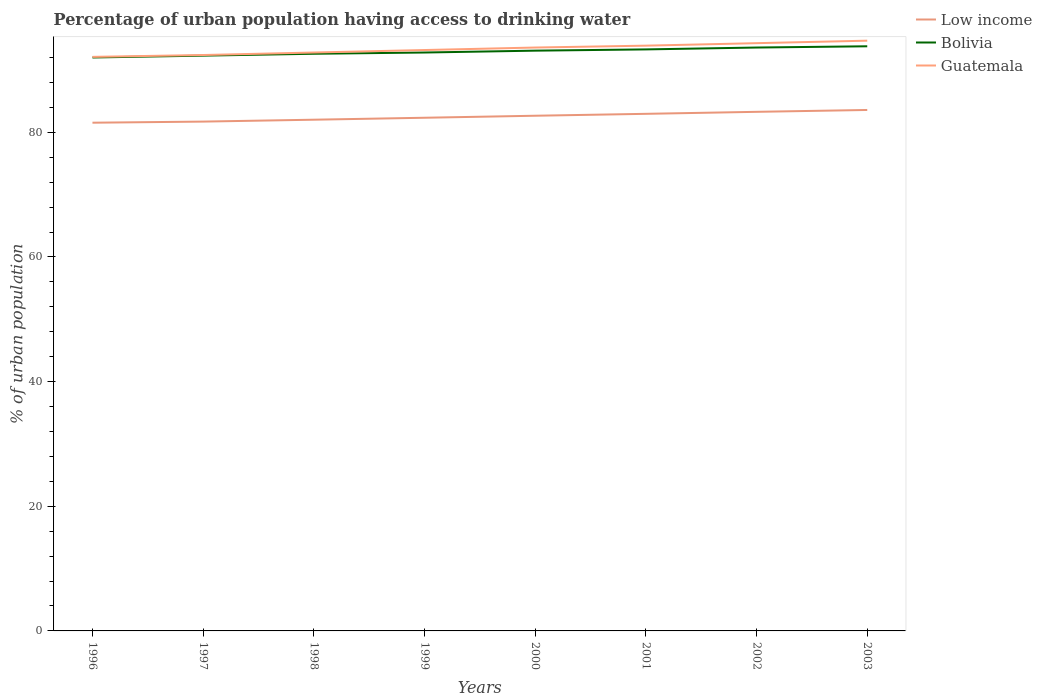How many different coloured lines are there?
Give a very brief answer. 3. Is the number of lines equal to the number of legend labels?
Offer a very short reply. Yes. Across all years, what is the maximum percentage of urban population having access to drinking water in Guatemala?
Give a very brief answer. 92.1. What is the total percentage of urban population having access to drinking water in Low income in the graph?
Your answer should be compact. -1.75. What is the difference between the highest and the second highest percentage of urban population having access to drinking water in Bolivia?
Your response must be concise. 1.8. Is the percentage of urban population having access to drinking water in Bolivia strictly greater than the percentage of urban population having access to drinking water in Guatemala over the years?
Make the answer very short. Yes. Are the values on the major ticks of Y-axis written in scientific E-notation?
Give a very brief answer. No. Does the graph contain grids?
Your answer should be very brief. No. Where does the legend appear in the graph?
Make the answer very short. Top right. What is the title of the graph?
Give a very brief answer. Percentage of urban population having access to drinking water. What is the label or title of the X-axis?
Your response must be concise. Years. What is the label or title of the Y-axis?
Offer a terse response. % of urban population. What is the % of urban population in Low income in 1996?
Ensure brevity in your answer.  81.54. What is the % of urban population in Bolivia in 1996?
Ensure brevity in your answer.  92. What is the % of urban population in Guatemala in 1996?
Offer a very short reply. 92.1. What is the % of urban population in Low income in 1997?
Give a very brief answer. 81.72. What is the % of urban population in Bolivia in 1997?
Your answer should be compact. 92.3. What is the % of urban population in Guatemala in 1997?
Ensure brevity in your answer.  92.4. What is the % of urban population in Low income in 1998?
Give a very brief answer. 82.02. What is the % of urban population of Bolivia in 1998?
Provide a short and direct response. 92.6. What is the % of urban population in Guatemala in 1998?
Offer a very short reply. 92.8. What is the % of urban population in Low income in 1999?
Make the answer very short. 82.33. What is the % of urban population in Bolivia in 1999?
Offer a terse response. 92.8. What is the % of urban population in Guatemala in 1999?
Give a very brief answer. 93.2. What is the % of urban population of Low income in 2000?
Provide a short and direct response. 82.66. What is the % of urban population of Bolivia in 2000?
Your answer should be very brief. 93.1. What is the % of urban population in Guatemala in 2000?
Provide a short and direct response. 93.6. What is the % of urban population in Low income in 2001?
Keep it short and to the point. 82.96. What is the % of urban population in Bolivia in 2001?
Provide a succinct answer. 93.3. What is the % of urban population of Guatemala in 2001?
Provide a short and direct response. 93.9. What is the % of urban population of Low income in 2002?
Make the answer very short. 83.28. What is the % of urban population of Bolivia in 2002?
Give a very brief answer. 93.6. What is the % of urban population of Guatemala in 2002?
Provide a succinct answer. 94.3. What is the % of urban population of Low income in 2003?
Your response must be concise. 83.58. What is the % of urban population of Bolivia in 2003?
Your answer should be very brief. 93.8. What is the % of urban population in Guatemala in 2003?
Make the answer very short. 94.7. Across all years, what is the maximum % of urban population in Low income?
Your response must be concise. 83.58. Across all years, what is the maximum % of urban population of Bolivia?
Make the answer very short. 93.8. Across all years, what is the maximum % of urban population of Guatemala?
Provide a short and direct response. 94.7. Across all years, what is the minimum % of urban population in Low income?
Make the answer very short. 81.54. Across all years, what is the minimum % of urban population of Bolivia?
Offer a terse response. 92. Across all years, what is the minimum % of urban population in Guatemala?
Your response must be concise. 92.1. What is the total % of urban population of Low income in the graph?
Your response must be concise. 660.1. What is the total % of urban population of Bolivia in the graph?
Ensure brevity in your answer.  743.5. What is the total % of urban population of Guatemala in the graph?
Your response must be concise. 747. What is the difference between the % of urban population in Low income in 1996 and that in 1997?
Provide a succinct answer. -0.18. What is the difference between the % of urban population of Bolivia in 1996 and that in 1997?
Offer a terse response. -0.3. What is the difference between the % of urban population in Low income in 1996 and that in 1998?
Ensure brevity in your answer.  -0.48. What is the difference between the % of urban population of Bolivia in 1996 and that in 1998?
Ensure brevity in your answer.  -0.6. What is the difference between the % of urban population of Guatemala in 1996 and that in 1998?
Make the answer very short. -0.7. What is the difference between the % of urban population of Low income in 1996 and that in 1999?
Your answer should be compact. -0.79. What is the difference between the % of urban population in Low income in 1996 and that in 2000?
Provide a succinct answer. -1.12. What is the difference between the % of urban population in Low income in 1996 and that in 2001?
Your answer should be very brief. -1.42. What is the difference between the % of urban population in Guatemala in 1996 and that in 2001?
Ensure brevity in your answer.  -1.8. What is the difference between the % of urban population in Low income in 1996 and that in 2002?
Keep it short and to the point. -1.75. What is the difference between the % of urban population of Bolivia in 1996 and that in 2002?
Keep it short and to the point. -1.6. What is the difference between the % of urban population in Guatemala in 1996 and that in 2002?
Offer a terse response. -2.2. What is the difference between the % of urban population in Low income in 1996 and that in 2003?
Keep it short and to the point. -2.04. What is the difference between the % of urban population in Guatemala in 1996 and that in 2003?
Offer a very short reply. -2.6. What is the difference between the % of urban population in Low income in 1997 and that in 1998?
Offer a very short reply. -0.31. What is the difference between the % of urban population of Bolivia in 1997 and that in 1998?
Give a very brief answer. -0.3. What is the difference between the % of urban population in Guatemala in 1997 and that in 1998?
Offer a terse response. -0.4. What is the difference between the % of urban population in Low income in 1997 and that in 1999?
Offer a very short reply. -0.62. What is the difference between the % of urban population in Low income in 1997 and that in 2000?
Offer a very short reply. -0.94. What is the difference between the % of urban population of Low income in 1997 and that in 2001?
Offer a very short reply. -1.25. What is the difference between the % of urban population in Bolivia in 1997 and that in 2001?
Keep it short and to the point. -1. What is the difference between the % of urban population in Guatemala in 1997 and that in 2001?
Make the answer very short. -1.5. What is the difference between the % of urban population in Low income in 1997 and that in 2002?
Offer a terse response. -1.57. What is the difference between the % of urban population in Bolivia in 1997 and that in 2002?
Offer a very short reply. -1.3. What is the difference between the % of urban population in Low income in 1997 and that in 2003?
Make the answer very short. -1.87. What is the difference between the % of urban population in Guatemala in 1997 and that in 2003?
Give a very brief answer. -2.3. What is the difference between the % of urban population of Low income in 1998 and that in 1999?
Keep it short and to the point. -0.31. What is the difference between the % of urban population in Low income in 1998 and that in 2000?
Your answer should be compact. -0.64. What is the difference between the % of urban population in Bolivia in 1998 and that in 2000?
Your response must be concise. -0.5. What is the difference between the % of urban population of Guatemala in 1998 and that in 2000?
Provide a succinct answer. -0.8. What is the difference between the % of urban population in Low income in 1998 and that in 2001?
Provide a succinct answer. -0.94. What is the difference between the % of urban population of Bolivia in 1998 and that in 2001?
Keep it short and to the point. -0.7. What is the difference between the % of urban population in Low income in 1998 and that in 2002?
Provide a succinct answer. -1.26. What is the difference between the % of urban population of Bolivia in 1998 and that in 2002?
Your answer should be compact. -1. What is the difference between the % of urban population of Low income in 1998 and that in 2003?
Provide a short and direct response. -1.56. What is the difference between the % of urban population in Bolivia in 1998 and that in 2003?
Ensure brevity in your answer.  -1.2. What is the difference between the % of urban population of Low income in 1999 and that in 2000?
Make the answer very short. -0.32. What is the difference between the % of urban population in Bolivia in 1999 and that in 2000?
Your answer should be very brief. -0.3. What is the difference between the % of urban population in Low income in 1999 and that in 2001?
Provide a short and direct response. -0.63. What is the difference between the % of urban population in Bolivia in 1999 and that in 2001?
Make the answer very short. -0.5. What is the difference between the % of urban population in Low income in 1999 and that in 2002?
Keep it short and to the point. -0.95. What is the difference between the % of urban population in Guatemala in 1999 and that in 2002?
Ensure brevity in your answer.  -1.1. What is the difference between the % of urban population in Low income in 1999 and that in 2003?
Make the answer very short. -1.25. What is the difference between the % of urban population of Bolivia in 1999 and that in 2003?
Give a very brief answer. -1. What is the difference between the % of urban population of Low income in 2000 and that in 2001?
Offer a terse response. -0.31. What is the difference between the % of urban population of Bolivia in 2000 and that in 2001?
Your response must be concise. -0.2. What is the difference between the % of urban population of Guatemala in 2000 and that in 2001?
Your answer should be compact. -0.3. What is the difference between the % of urban population of Low income in 2000 and that in 2002?
Keep it short and to the point. -0.63. What is the difference between the % of urban population in Bolivia in 2000 and that in 2002?
Keep it short and to the point. -0.5. What is the difference between the % of urban population of Guatemala in 2000 and that in 2002?
Provide a succinct answer. -0.7. What is the difference between the % of urban population of Low income in 2000 and that in 2003?
Make the answer very short. -0.93. What is the difference between the % of urban population of Guatemala in 2000 and that in 2003?
Give a very brief answer. -1.1. What is the difference between the % of urban population of Low income in 2001 and that in 2002?
Offer a very short reply. -0.32. What is the difference between the % of urban population in Low income in 2001 and that in 2003?
Offer a terse response. -0.62. What is the difference between the % of urban population of Bolivia in 2001 and that in 2003?
Provide a short and direct response. -0.5. What is the difference between the % of urban population of Guatemala in 2001 and that in 2003?
Make the answer very short. -0.8. What is the difference between the % of urban population in Low income in 2002 and that in 2003?
Provide a short and direct response. -0.3. What is the difference between the % of urban population in Guatemala in 2002 and that in 2003?
Make the answer very short. -0.4. What is the difference between the % of urban population of Low income in 1996 and the % of urban population of Bolivia in 1997?
Provide a short and direct response. -10.76. What is the difference between the % of urban population of Low income in 1996 and the % of urban population of Guatemala in 1997?
Provide a short and direct response. -10.86. What is the difference between the % of urban population in Bolivia in 1996 and the % of urban population in Guatemala in 1997?
Offer a very short reply. -0.4. What is the difference between the % of urban population in Low income in 1996 and the % of urban population in Bolivia in 1998?
Keep it short and to the point. -11.06. What is the difference between the % of urban population of Low income in 1996 and the % of urban population of Guatemala in 1998?
Offer a terse response. -11.26. What is the difference between the % of urban population of Low income in 1996 and the % of urban population of Bolivia in 1999?
Offer a very short reply. -11.26. What is the difference between the % of urban population in Low income in 1996 and the % of urban population in Guatemala in 1999?
Keep it short and to the point. -11.66. What is the difference between the % of urban population in Bolivia in 1996 and the % of urban population in Guatemala in 1999?
Provide a short and direct response. -1.2. What is the difference between the % of urban population in Low income in 1996 and the % of urban population in Bolivia in 2000?
Ensure brevity in your answer.  -11.56. What is the difference between the % of urban population in Low income in 1996 and the % of urban population in Guatemala in 2000?
Your answer should be compact. -12.06. What is the difference between the % of urban population of Bolivia in 1996 and the % of urban population of Guatemala in 2000?
Provide a succinct answer. -1.6. What is the difference between the % of urban population of Low income in 1996 and the % of urban population of Bolivia in 2001?
Provide a short and direct response. -11.76. What is the difference between the % of urban population in Low income in 1996 and the % of urban population in Guatemala in 2001?
Make the answer very short. -12.36. What is the difference between the % of urban population in Bolivia in 1996 and the % of urban population in Guatemala in 2001?
Keep it short and to the point. -1.9. What is the difference between the % of urban population of Low income in 1996 and the % of urban population of Bolivia in 2002?
Give a very brief answer. -12.06. What is the difference between the % of urban population of Low income in 1996 and the % of urban population of Guatemala in 2002?
Offer a very short reply. -12.76. What is the difference between the % of urban population in Low income in 1996 and the % of urban population in Bolivia in 2003?
Offer a terse response. -12.26. What is the difference between the % of urban population of Low income in 1996 and the % of urban population of Guatemala in 2003?
Ensure brevity in your answer.  -13.16. What is the difference between the % of urban population of Low income in 1997 and the % of urban population of Bolivia in 1998?
Your answer should be very brief. -10.88. What is the difference between the % of urban population in Low income in 1997 and the % of urban population in Guatemala in 1998?
Ensure brevity in your answer.  -11.08. What is the difference between the % of urban population of Low income in 1997 and the % of urban population of Bolivia in 1999?
Your answer should be very brief. -11.08. What is the difference between the % of urban population in Low income in 1997 and the % of urban population in Guatemala in 1999?
Provide a succinct answer. -11.48. What is the difference between the % of urban population in Low income in 1997 and the % of urban population in Bolivia in 2000?
Your answer should be very brief. -11.38. What is the difference between the % of urban population of Low income in 1997 and the % of urban population of Guatemala in 2000?
Offer a terse response. -11.88. What is the difference between the % of urban population of Bolivia in 1997 and the % of urban population of Guatemala in 2000?
Your answer should be very brief. -1.3. What is the difference between the % of urban population in Low income in 1997 and the % of urban population in Bolivia in 2001?
Provide a succinct answer. -11.58. What is the difference between the % of urban population in Low income in 1997 and the % of urban population in Guatemala in 2001?
Your response must be concise. -12.18. What is the difference between the % of urban population of Low income in 1997 and the % of urban population of Bolivia in 2002?
Ensure brevity in your answer.  -11.88. What is the difference between the % of urban population of Low income in 1997 and the % of urban population of Guatemala in 2002?
Keep it short and to the point. -12.58. What is the difference between the % of urban population in Low income in 1997 and the % of urban population in Bolivia in 2003?
Give a very brief answer. -12.08. What is the difference between the % of urban population in Low income in 1997 and the % of urban population in Guatemala in 2003?
Your answer should be very brief. -12.98. What is the difference between the % of urban population in Bolivia in 1997 and the % of urban population in Guatemala in 2003?
Give a very brief answer. -2.4. What is the difference between the % of urban population of Low income in 1998 and the % of urban population of Bolivia in 1999?
Offer a very short reply. -10.78. What is the difference between the % of urban population of Low income in 1998 and the % of urban population of Guatemala in 1999?
Provide a succinct answer. -11.18. What is the difference between the % of urban population in Bolivia in 1998 and the % of urban population in Guatemala in 1999?
Ensure brevity in your answer.  -0.6. What is the difference between the % of urban population in Low income in 1998 and the % of urban population in Bolivia in 2000?
Give a very brief answer. -11.08. What is the difference between the % of urban population in Low income in 1998 and the % of urban population in Guatemala in 2000?
Offer a very short reply. -11.58. What is the difference between the % of urban population in Low income in 1998 and the % of urban population in Bolivia in 2001?
Ensure brevity in your answer.  -11.28. What is the difference between the % of urban population of Low income in 1998 and the % of urban population of Guatemala in 2001?
Make the answer very short. -11.88. What is the difference between the % of urban population of Low income in 1998 and the % of urban population of Bolivia in 2002?
Offer a terse response. -11.58. What is the difference between the % of urban population of Low income in 1998 and the % of urban population of Guatemala in 2002?
Your response must be concise. -12.28. What is the difference between the % of urban population in Low income in 1998 and the % of urban population in Bolivia in 2003?
Ensure brevity in your answer.  -11.78. What is the difference between the % of urban population in Low income in 1998 and the % of urban population in Guatemala in 2003?
Your answer should be compact. -12.68. What is the difference between the % of urban population in Bolivia in 1998 and the % of urban population in Guatemala in 2003?
Give a very brief answer. -2.1. What is the difference between the % of urban population of Low income in 1999 and the % of urban population of Bolivia in 2000?
Your answer should be compact. -10.77. What is the difference between the % of urban population of Low income in 1999 and the % of urban population of Guatemala in 2000?
Give a very brief answer. -11.27. What is the difference between the % of urban population of Bolivia in 1999 and the % of urban population of Guatemala in 2000?
Provide a short and direct response. -0.8. What is the difference between the % of urban population in Low income in 1999 and the % of urban population in Bolivia in 2001?
Provide a short and direct response. -10.97. What is the difference between the % of urban population in Low income in 1999 and the % of urban population in Guatemala in 2001?
Ensure brevity in your answer.  -11.57. What is the difference between the % of urban population in Low income in 1999 and the % of urban population in Bolivia in 2002?
Offer a very short reply. -11.27. What is the difference between the % of urban population of Low income in 1999 and the % of urban population of Guatemala in 2002?
Provide a succinct answer. -11.97. What is the difference between the % of urban population of Bolivia in 1999 and the % of urban population of Guatemala in 2002?
Keep it short and to the point. -1.5. What is the difference between the % of urban population in Low income in 1999 and the % of urban population in Bolivia in 2003?
Provide a short and direct response. -11.47. What is the difference between the % of urban population in Low income in 1999 and the % of urban population in Guatemala in 2003?
Your answer should be very brief. -12.37. What is the difference between the % of urban population of Low income in 2000 and the % of urban population of Bolivia in 2001?
Provide a short and direct response. -10.64. What is the difference between the % of urban population of Low income in 2000 and the % of urban population of Guatemala in 2001?
Your response must be concise. -11.24. What is the difference between the % of urban population of Bolivia in 2000 and the % of urban population of Guatemala in 2001?
Give a very brief answer. -0.8. What is the difference between the % of urban population in Low income in 2000 and the % of urban population in Bolivia in 2002?
Provide a short and direct response. -10.94. What is the difference between the % of urban population of Low income in 2000 and the % of urban population of Guatemala in 2002?
Offer a terse response. -11.64. What is the difference between the % of urban population in Low income in 2000 and the % of urban population in Bolivia in 2003?
Make the answer very short. -11.14. What is the difference between the % of urban population in Low income in 2000 and the % of urban population in Guatemala in 2003?
Ensure brevity in your answer.  -12.04. What is the difference between the % of urban population in Bolivia in 2000 and the % of urban population in Guatemala in 2003?
Offer a very short reply. -1.6. What is the difference between the % of urban population of Low income in 2001 and the % of urban population of Bolivia in 2002?
Keep it short and to the point. -10.64. What is the difference between the % of urban population in Low income in 2001 and the % of urban population in Guatemala in 2002?
Ensure brevity in your answer.  -11.34. What is the difference between the % of urban population in Low income in 2001 and the % of urban population in Bolivia in 2003?
Provide a short and direct response. -10.84. What is the difference between the % of urban population in Low income in 2001 and the % of urban population in Guatemala in 2003?
Provide a succinct answer. -11.74. What is the difference between the % of urban population in Low income in 2002 and the % of urban population in Bolivia in 2003?
Your answer should be very brief. -10.52. What is the difference between the % of urban population in Low income in 2002 and the % of urban population in Guatemala in 2003?
Make the answer very short. -11.42. What is the difference between the % of urban population in Bolivia in 2002 and the % of urban population in Guatemala in 2003?
Your answer should be compact. -1.1. What is the average % of urban population of Low income per year?
Offer a terse response. 82.51. What is the average % of urban population in Bolivia per year?
Give a very brief answer. 92.94. What is the average % of urban population in Guatemala per year?
Offer a terse response. 93.38. In the year 1996, what is the difference between the % of urban population in Low income and % of urban population in Bolivia?
Provide a short and direct response. -10.46. In the year 1996, what is the difference between the % of urban population of Low income and % of urban population of Guatemala?
Provide a succinct answer. -10.56. In the year 1997, what is the difference between the % of urban population of Low income and % of urban population of Bolivia?
Your response must be concise. -10.58. In the year 1997, what is the difference between the % of urban population in Low income and % of urban population in Guatemala?
Provide a succinct answer. -10.68. In the year 1997, what is the difference between the % of urban population in Bolivia and % of urban population in Guatemala?
Offer a terse response. -0.1. In the year 1998, what is the difference between the % of urban population in Low income and % of urban population in Bolivia?
Provide a succinct answer. -10.58. In the year 1998, what is the difference between the % of urban population in Low income and % of urban population in Guatemala?
Provide a succinct answer. -10.78. In the year 1998, what is the difference between the % of urban population of Bolivia and % of urban population of Guatemala?
Ensure brevity in your answer.  -0.2. In the year 1999, what is the difference between the % of urban population of Low income and % of urban population of Bolivia?
Ensure brevity in your answer.  -10.47. In the year 1999, what is the difference between the % of urban population in Low income and % of urban population in Guatemala?
Your response must be concise. -10.87. In the year 1999, what is the difference between the % of urban population in Bolivia and % of urban population in Guatemala?
Provide a succinct answer. -0.4. In the year 2000, what is the difference between the % of urban population in Low income and % of urban population in Bolivia?
Offer a terse response. -10.44. In the year 2000, what is the difference between the % of urban population in Low income and % of urban population in Guatemala?
Provide a short and direct response. -10.94. In the year 2000, what is the difference between the % of urban population of Bolivia and % of urban population of Guatemala?
Your answer should be compact. -0.5. In the year 2001, what is the difference between the % of urban population in Low income and % of urban population in Bolivia?
Make the answer very short. -10.34. In the year 2001, what is the difference between the % of urban population of Low income and % of urban population of Guatemala?
Offer a very short reply. -10.94. In the year 2001, what is the difference between the % of urban population in Bolivia and % of urban population in Guatemala?
Keep it short and to the point. -0.6. In the year 2002, what is the difference between the % of urban population in Low income and % of urban population in Bolivia?
Give a very brief answer. -10.32. In the year 2002, what is the difference between the % of urban population in Low income and % of urban population in Guatemala?
Keep it short and to the point. -11.02. In the year 2002, what is the difference between the % of urban population in Bolivia and % of urban population in Guatemala?
Offer a terse response. -0.7. In the year 2003, what is the difference between the % of urban population of Low income and % of urban population of Bolivia?
Your answer should be very brief. -10.22. In the year 2003, what is the difference between the % of urban population in Low income and % of urban population in Guatemala?
Provide a short and direct response. -11.12. In the year 2003, what is the difference between the % of urban population in Bolivia and % of urban population in Guatemala?
Keep it short and to the point. -0.9. What is the ratio of the % of urban population in Low income in 1996 to that in 1997?
Give a very brief answer. 1. What is the ratio of the % of urban population in Bolivia in 1996 to that in 1997?
Your response must be concise. 1. What is the ratio of the % of urban population in Guatemala in 1996 to that in 1998?
Your answer should be very brief. 0.99. What is the ratio of the % of urban population in Low income in 1996 to that in 1999?
Ensure brevity in your answer.  0.99. What is the ratio of the % of urban population of Low income in 1996 to that in 2000?
Offer a very short reply. 0.99. What is the ratio of the % of urban population of Guatemala in 1996 to that in 2000?
Offer a terse response. 0.98. What is the ratio of the % of urban population of Low income in 1996 to that in 2001?
Your answer should be very brief. 0.98. What is the ratio of the % of urban population of Bolivia in 1996 to that in 2001?
Keep it short and to the point. 0.99. What is the ratio of the % of urban population in Guatemala in 1996 to that in 2001?
Make the answer very short. 0.98. What is the ratio of the % of urban population in Bolivia in 1996 to that in 2002?
Your response must be concise. 0.98. What is the ratio of the % of urban population in Guatemala in 1996 to that in 2002?
Keep it short and to the point. 0.98. What is the ratio of the % of urban population of Low income in 1996 to that in 2003?
Your answer should be compact. 0.98. What is the ratio of the % of urban population in Bolivia in 1996 to that in 2003?
Keep it short and to the point. 0.98. What is the ratio of the % of urban population in Guatemala in 1996 to that in 2003?
Ensure brevity in your answer.  0.97. What is the ratio of the % of urban population in Low income in 1997 to that in 1998?
Your response must be concise. 1. What is the ratio of the % of urban population in Bolivia in 1997 to that in 1998?
Give a very brief answer. 1. What is the ratio of the % of urban population of Guatemala in 1997 to that in 1998?
Ensure brevity in your answer.  1. What is the ratio of the % of urban population of Bolivia in 1997 to that in 1999?
Provide a succinct answer. 0.99. What is the ratio of the % of urban population of Low income in 1997 to that in 2000?
Provide a short and direct response. 0.99. What is the ratio of the % of urban population of Bolivia in 1997 to that in 2000?
Provide a short and direct response. 0.99. What is the ratio of the % of urban population in Guatemala in 1997 to that in 2000?
Provide a short and direct response. 0.99. What is the ratio of the % of urban population of Low income in 1997 to that in 2001?
Ensure brevity in your answer.  0.98. What is the ratio of the % of urban population in Bolivia in 1997 to that in 2001?
Provide a succinct answer. 0.99. What is the ratio of the % of urban population of Low income in 1997 to that in 2002?
Offer a terse response. 0.98. What is the ratio of the % of urban population in Bolivia in 1997 to that in 2002?
Ensure brevity in your answer.  0.99. What is the ratio of the % of urban population of Guatemala in 1997 to that in 2002?
Your answer should be compact. 0.98. What is the ratio of the % of urban population of Low income in 1997 to that in 2003?
Provide a succinct answer. 0.98. What is the ratio of the % of urban population in Bolivia in 1997 to that in 2003?
Your answer should be very brief. 0.98. What is the ratio of the % of urban population in Guatemala in 1997 to that in 2003?
Ensure brevity in your answer.  0.98. What is the ratio of the % of urban population of Low income in 1998 to that in 1999?
Offer a terse response. 1. What is the ratio of the % of urban population of Bolivia in 1998 to that in 1999?
Provide a succinct answer. 1. What is the ratio of the % of urban population of Guatemala in 1998 to that in 1999?
Your response must be concise. 1. What is the ratio of the % of urban population of Low income in 1998 to that in 2000?
Offer a terse response. 0.99. What is the ratio of the % of urban population of Guatemala in 1998 to that in 2000?
Your answer should be very brief. 0.99. What is the ratio of the % of urban population in Low income in 1998 to that in 2001?
Offer a terse response. 0.99. What is the ratio of the % of urban population in Guatemala in 1998 to that in 2001?
Ensure brevity in your answer.  0.99. What is the ratio of the % of urban population of Low income in 1998 to that in 2002?
Keep it short and to the point. 0.98. What is the ratio of the % of urban population in Bolivia in 1998 to that in 2002?
Offer a terse response. 0.99. What is the ratio of the % of urban population of Guatemala in 1998 to that in 2002?
Ensure brevity in your answer.  0.98. What is the ratio of the % of urban population in Low income in 1998 to that in 2003?
Your answer should be compact. 0.98. What is the ratio of the % of urban population in Bolivia in 1998 to that in 2003?
Offer a very short reply. 0.99. What is the ratio of the % of urban population in Guatemala in 1998 to that in 2003?
Offer a terse response. 0.98. What is the ratio of the % of urban population in Bolivia in 1999 to that in 2000?
Your response must be concise. 1. What is the ratio of the % of urban population in Low income in 1999 to that in 2001?
Your response must be concise. 0.99. What is the ratio of the % of urban population in Guatemala in 1999 to that in 2001?
Give a very brief answer. 0.99. What is the ratio of the % of urban population of Low income in 1999 to that in 2002?
Provide a succinct answer. 0.99. What is the ratio of the % of urban population of Bolivia in 1999 to that in 2002?
Offer a terse response. 0.99. What is the ratio of the % of urban population in Guatemala in 1999 to that in 2002?
Keep it short and to the point. 0.99. What is the ratio of the % of urban population in Low income in 1999 to that in 2003?
Your answer should be compact. 0.98. What is the ratio of the % of urban population of Bolivia in 1999 to that in 2003?
Offer a very short reply. 0.99. What is the ratio of the % of urban population of Guatemala in 1999 to that in 2003?
Provide a succinct answer. 0.98. What is the ratio of the % of urban population of Low income in 2000 to that in 2001?
Provide a short and direct response. 1. What is the ratio of the % of urban population of Bolivia in 2000 to that in 2002?
Offer a very short reply. 0.99. What is the ratio of the % of urban population in Low income in 2000 to that in 2003?
Your answer should be compact. 0.99. What is the ratio of the % of urban population in Bolivia in 2000 to that in 2003?
Make the answer very short. 0.99. What is the ratio of the % of urban population in Guatemala in 2000 to that in 2003?
Offer a terse response. 0.99. What is the ratio of the % of urban population of Low income in 2001 to that in 2003?
Provide a succinct answer. 0.99. What is the ratio of the % of urban population of Bolivia in 2001 to that in 2003?
Ensure brevity in your answer.  0.99. What is the ratio of the % of urban population of Guatemala in 2001 to that in 2003?
Offer a terse response. 0.99. What is the ratio of the % of urban population in Bolivia in 2002 to that in 2003?
Provide a succinct answer. 1. What is the difference between the highest and the second highest % of urban population in Low income?
Provide a short and direct response. 0.3. What is the difference between the highest and the second highest % of urban population of Bolivia?
Your response must be concise. 0.2. What is the difference between the highest and the second highest % of urban population of Guatemala?
Give a very brief answer. 0.4. What is the difference between the highest and the lowest % of urban population of Low income?
Give a very brief answer. 2.04. What is the difference between the highest and the lowest % of urban population in Guatemala?
Provide a short and direct response. 2.6. 